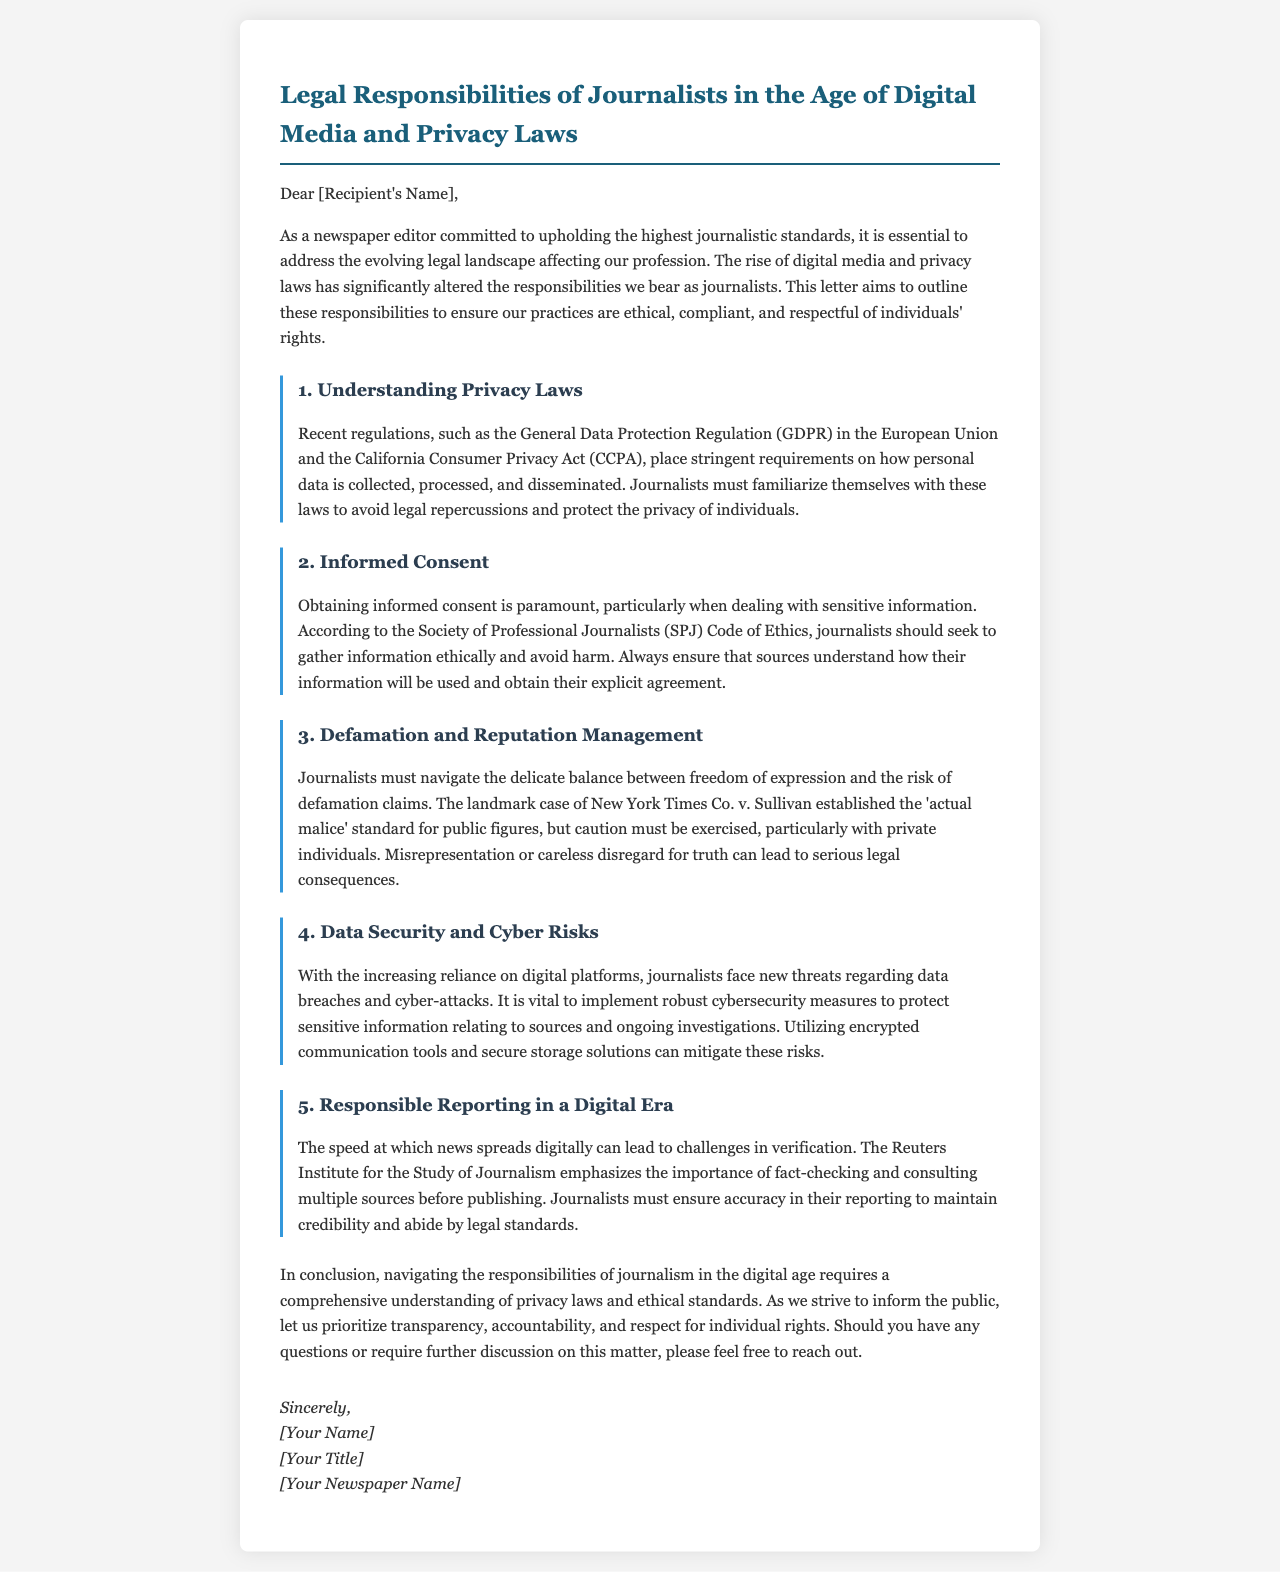What is the title of the letter? The title is clearly stated at the top of the document, introducing the main topic of the letter.
Answer: Legal Responsibilities of Journalists in the Age of Digital Media and Privacy Laws Who is addressed in the letter? The letter begins with a salutation that indicates the recipient’s role, though the specific name is not provided here.
Answer: [Recipient's Name] What are two regulations mentioned in the document? The document lists regulations that affect journalists, detailing significant laws they must understand.
Answer: GDPR and CCPA What is paramount when dealing with sensitive information? The letter highlights a critical ethical consideration in journalism with sensitive data, drawing from professional guidelines.
Answer: Informed consent What does the SPJ Code of Ethics emphasize? The letter refers to a guiding document that encourages ethical behavior among journalists, especially regarding information gathering.
Answer: Ethical information gathering Which landmark case is referred to regarding defamation? The letter discusses a significant legal case that influences how defamation is evaluated in journalism, particularly its repercussions.
Answer: New York Times Co. v. Sullivan What tool is recommended for protecting sensitive information? The document suggests strategies to secure data against increasing digital threats journalists face concerning their sources.
Answer: Encrypted communication tools What does the document encourage to maintain credibility? The letter stresses an important practice for journalists in the digital age to ensure the trustworthiness of their reported information.
Answer: Fact-checking 